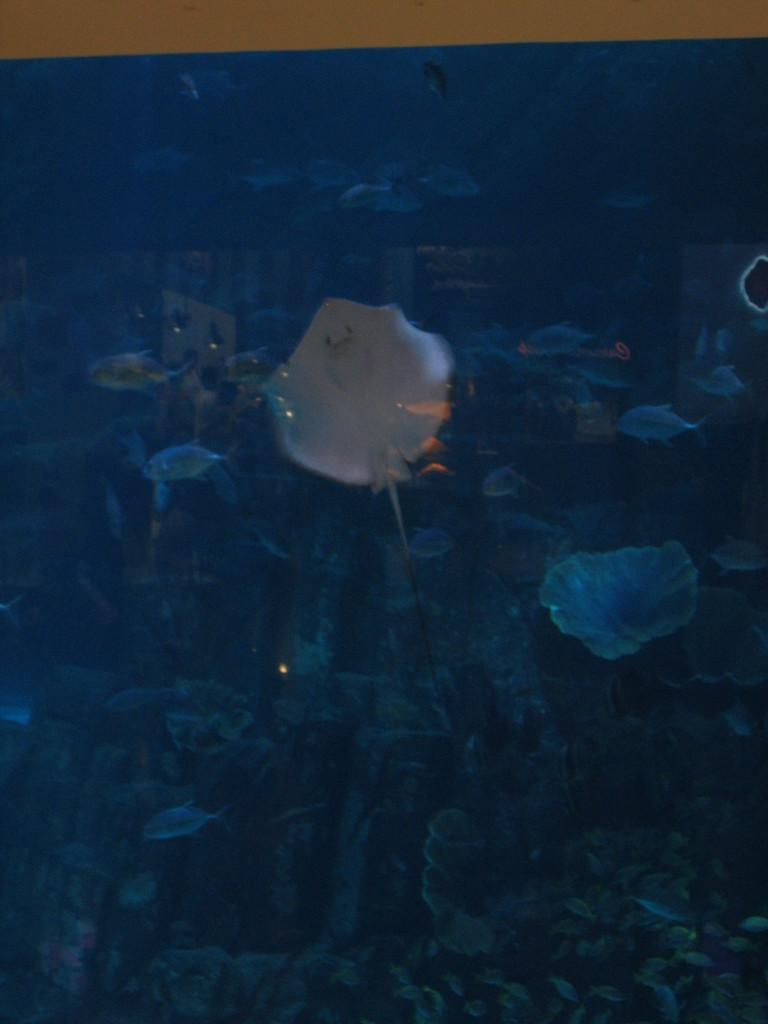What is the main subject of the picture? The main subject of the picture is an aquarium. What can be found inside the aquarium? The aquarium contains different kinds of fishes. Are there any other elements in the aquarium besides the fishes? Yes, there are water plants in the aquarium. What time of day is it in the image, considering the presence of an afternoon light? There is no mention of an afternoon light or any specific time of day in the image, as it only features an aquarium with fishes and water plants. 